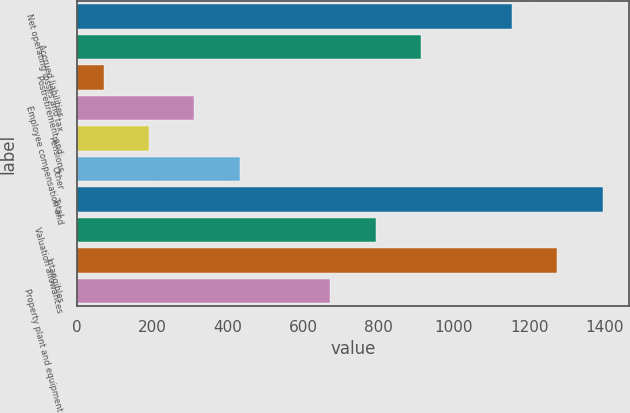Convert chart to OTSL. <chart><loc_0><loc_0><loc_500><loc_500><bar_chart><fcel>Net operating losses and tax<fcel>Accrued liabilities<fcel>Postretirement and<fcel>Employee compensation and<fcel>Pensions<fcel>Other<fcel>Total<fcel>Valuation allowances<fcel>Intangibles<fcel>Property plant and equipment<nl><fcel>1153.6<fcel>912.8<fcel>70<fcel>310.8<fcel>190.4<fcel>431.2<fcel>1394.4<fcel>792.4<fcel>1274<fcel>672<nl></chart> 